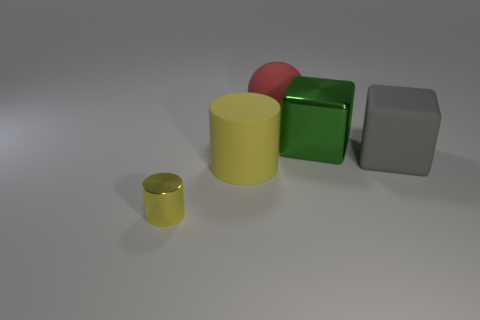Is there a big matte thing of the same color as the small metal object?
Offer a very short reply. Yes. How many shiny objects are either yellow cylinders or big cylinders?
Make the answer very short. 1. There is another cylinder that is the same color as the shiny cylinder; what size is it?
Offer a very short reply. Large. There is a thing that is behind the metal object that is behind the shiny cylinder; what is it made of?
Keep it short and to the point. Rubber. How many objects are either large gray rubber objects or objects to the right of the sphere?
Offer a very short reply. 2. What size is the green object that is the same material as the tiny yellow thing?
Your answer should be compact. Large. How many cyan objects are matte cylinders or small cylinders?
Offer a very short reply. 0. There is a large rubber object that is the same color as the tiny thing; what shape is it?
Ensure brevity in your answer.  Cylinder. Does the metal thing right of the small shiny thing have the same shape as the matte object that is to the right of the ball?
Offer a very short reply. Yes. What number of tiny yellow blocks are there?
Provide a short and direct response. 0. 